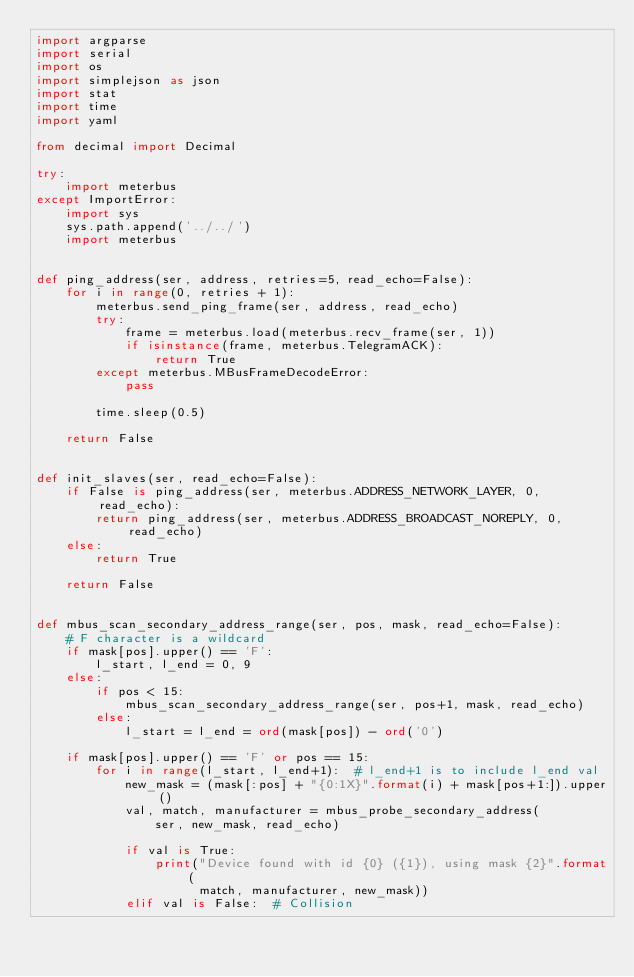Convert code to text. <code><loc_0><loc_0><loc_500><loc_500><_Python_>import argparse
import serial
import os
import simplejson as json
import stat
import time
import yaml

from decimal import Decimal

try:
    import meterbus
except ImportError:
    import sys
    sys.path.append('../../')
    import meterbus


def ping_address(ser, address, retries=5, read_echo=False):
    for i in range(0, retries + 1):
        meterbus.send_ping_frame(ser, address, read_echo)
        try:
            frame = meterbus.load(meterbus.recv_frame(ser, 1))
            if isinstance(frame, meterbus.TelegramACK):
                return True
        except meterbus.MBusFrameDecodeError:
            pass

        time.sleep(0.5)

    return False


def init_slaves(ser, read_echo=False):
    if False is ping_address(ser, meterbus.ADDRESS_NETWORK_LAYER, 0, read_echo):
        return ping_address(ser, meterbus.ADDRESS_BROADCAST_NOREPLY, 0, read_echo)
    else:
        return True

    return False


def mbus_scan_secondary_address_range(ser, pos, mask, read_echo=False):
    # F character is a wildcard
    if mask[pos].upper() == 'F':
        l_start, l_end = 0, 9
    else:
        if pos < 15:
            mbus_scan_secondary_address_range(ser, pos+1, mask, read_echo)
        else:
            l_start = l_end = ord(mask[pos]) - ord('0')

    if mask[pos].upper() == 'F' or pos == 15:
        for i in range(l_start, l_end+1):  # l_end+1 is to include l_end val
            new_mask = (mask[:pos] + "{0:1X}".format(i) + mask[pos+1:]).upper()
            val, match, manufacturer = mbus_probe_secondary_address(
                ser, new_mask, read_echo)

            if val is True:
                print("Device found with id {0} ({1}), using mask {2}".format(
                      match, manufacturer, new_mask))
            elif val is False:  # Collision</code> 